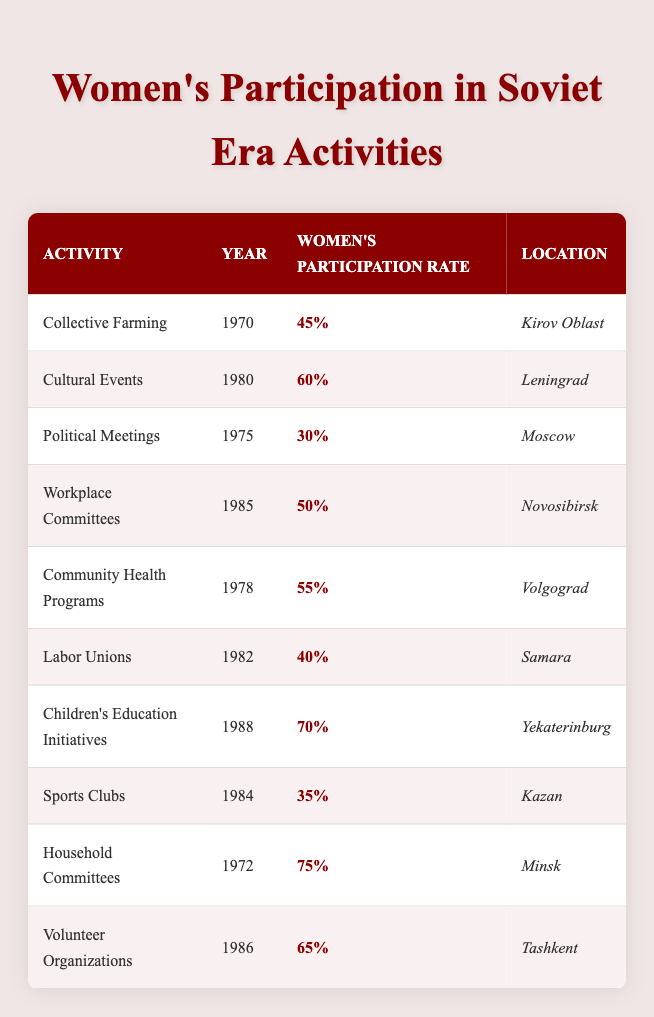What was the women's participation rate in Collective Farming in Kirov Oblast in 1970? The table shows that in 1970, the women's participation rate in Collective Farming in Kirov Oblast was 45%. To find this, I simply look for the row corresponding to Collective Farming and read the percentage listed.
Answer: 45% Which activity had the highest women's participation rate? By examining each row in the table, I see that Household Committees, with a participation rate of 75%, is the highest. I compare all the participation rates presented in the table to determine this.
Answer: 75% How many activities had a women's participation rate of 50% or more? I need to count the rows where the participation rate is greater than or equal to 50%. The eligible activities are: Cultural Events (60%), Community Health Programs (55%), Children's Education Initiatives (70%), Household Committees (75%), and Volunteer Organizations (65%). Thus, there are five activities total.
Answer: 5 Was the participation rate in Labor Unions lower than 50%? Looking at the table, the participation rate for Labor Unions is 40%, which is indeed lower than 50%. I find the corresponding row for Labor Unions and check the value.
Answer: Yes What is the average participation rate of women in activities from the 1980s listed in the table? The activities from the 1980s in the table are Cultural Events (60%), Labor Unions (40%), and Children's Education Initiatives (70%), and also Volunteer Organizations (65%). Adding these rates gives a sum of 60 + 40 + 70 + 65 = 235. There are four data points here, so I divide 235 by 4 to find the average: 235 / 4 = 58.75.
Answer: 58.75 In which location was the lowest women's participation rate recorded and what was that percentage? By scanning through the location entries in the table and their corresponding participation rates, I see that Kazan reported the lowest rate at 35% in Sports Clubs. I identify the row with Sports Clubs and note the percentage.
Answer: Kazan, 35% What was the women's participation rate in Political Meetings in Moscow, and how does it compare to that in Volunteer Organizations in Tashkent? The table indicates that the participation rate in Political Meetings in Moscow was 30%, while in Tashkent, it was 65% for Volunteer Organizations. Comparing these two rates, 65% is significantly higher than 30%.
Answer: 30%, 65% How many activities were recorded before the year 1980 with women's participation rates above 50%? I check the activities listed before 1980, which are Collective Farming (1970, 45%), Political Meetings (1975, 30%), and Community Health Programs (1978, 55%). Only Community Health Programs has a rate above 50%. Therefore, there is only one such activity.
Answer: 1 